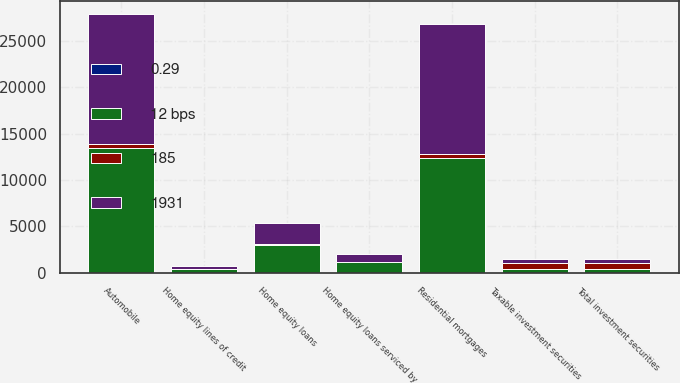Convert chart. <chart><loc_0><loc_0><loc_500><loc_500><stacked_bar_chart><ecel><fcel>Taxable investment securities<fcel>Total investment securities<fcel>Residential mortgages<fcel>Home equity loans<fcel>Home equity lines of credit<fcel>Home equity loans serviced by<fcel>Automobile<nl><fcel>1931<fcel>455<fcel>455<fcel>14005<fcel>2180<fcel>281<fcel>867<fcel>13953<nl><fcel>185<fcel>584<fcel>584<fcel>504<fcel>123<fcel>7<fcel>62<fcel>411<nl><fcel>0.29<fcel>2.37<fcel>2.37<fcel>3.6<fcel>5.64<fcel>2.41<fcel>7.11<fcel>2.94<nl><fcel>12 bps<fcel>455<fcel>455<fcel>12338<fcel>3025<fcel>453<fcel>1117<fcel>13516<nl></chart> 